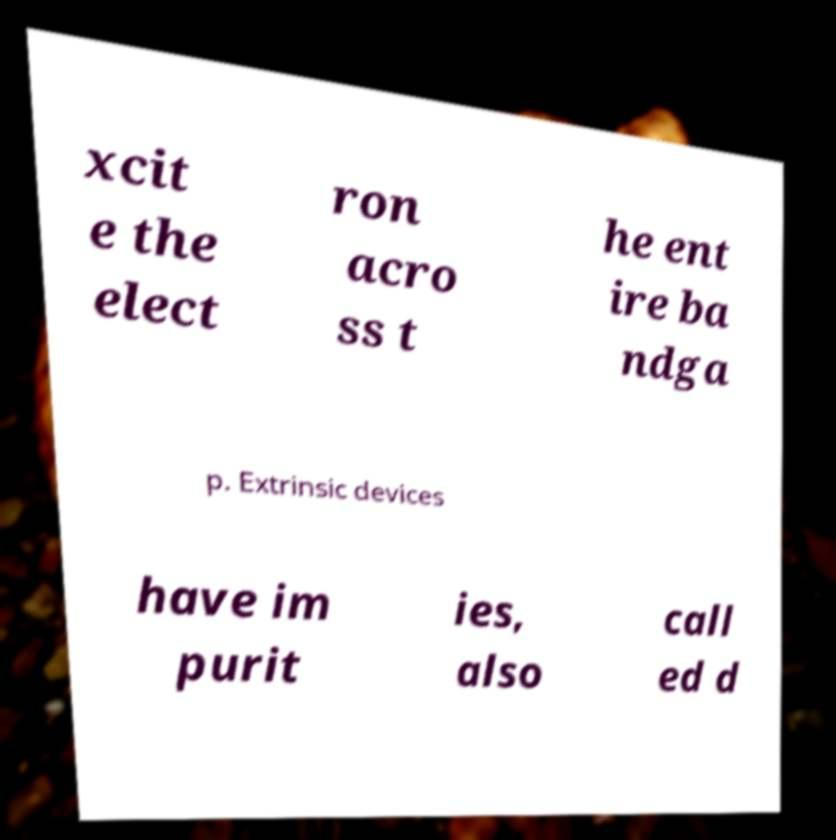Please read and relay the text visible in this image. What does it say? xcit e the elect ron acro ss t he ent ire ba ndga p. Extrinsic devices have im purit ies, also call ed d 